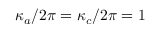<formula> <loc_0><loc_0><loc_500><loc_500>\kappa _ { a } / 2 \pi = \kappa _ { c } / 2 \pi = 1</formula> 